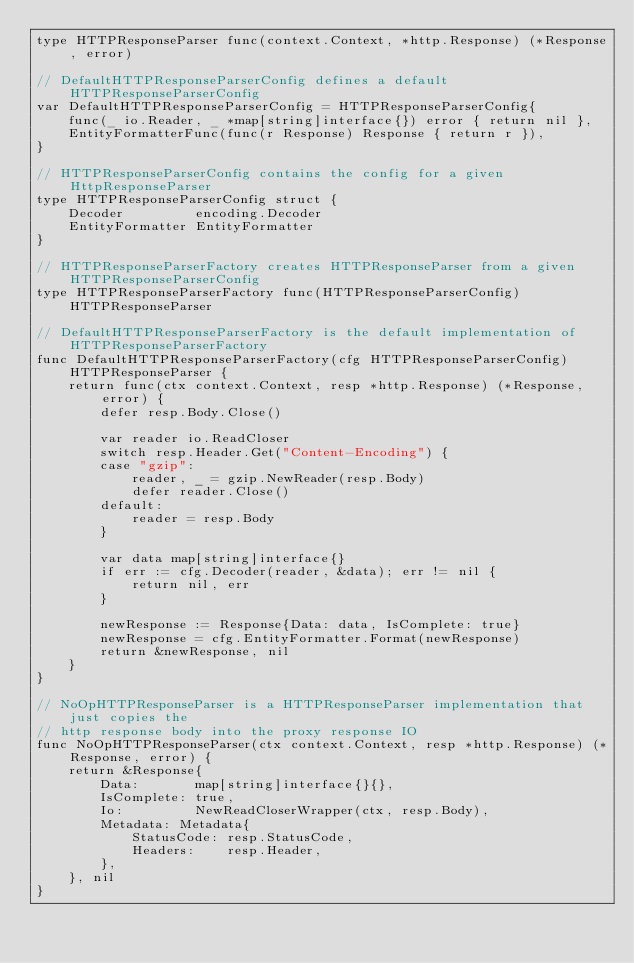<code> <loc_0><loc_0><loc_500><loc_500><_Go_>type HTTPResponseParser func(context.Context, *http.Response) (*Response, error)

// DefaultHTTPResponseParserConfig defines a default HTTPResponseParserConfig
var DefaultHTTPResponseParserConfig = HTTPResponseParserConfig{
	func(_ io.Reader, _ *map[string]interface{}) error { return nil },
	EntityFormatterFunc(func(r Response) Response { return r }),
}

// HTTPResponseParserConfig contains the config for a given HttpResponseParser
type HTTPResponseParserConfig struct {
	Decoder         encoding.Decoder
	EntityFormatter EntityFormatter
}

// HTTPResponseParserFactory creates HTTPResponseParser from a given HTTPResponseParserConfig
type HTTPResponseParserFactory func(HTTPResponseParserConfig) HTTPResponseParser

// DefaultHTTPResponseParserFactory is the default implementation of HTTPResponseParserFactory
func DefaultHTTPResponseParserFactory(cfg HTTPResponseParserConfig) HTTPResponseParser {
	return func(ctx context.Context, resp *http.Response) (*Response, error) {
		defer resp.Body.Close()

		var reader io.ReadCloser
		switch resp.Header.Get("Content-Encoding") {
		case "gzip":
			reader, _ = gzip.NewReader(resp.Body)
			defer reader.Close()
		default:
			reader = resp.Body
		}

		var data map[string]interface{}
		if err := cfg.Decoder(reader, &data); err != nil {
			return nil, err
		}

		newResponse := Response{Data: data, IsComplete: true}
		newResponse = cfg.EntityFormatter.Format(newResponse)
		return &newResponse, nil
	}
}

// NoOpHTTPResponseParser is a HTTPResponseParser implementation that just copies the
// http response body into the proxy response IO
func NoOpHTTPResponseParser(ctx context.Context, resp *http.Response) (*Response, error) {
	return &Response{
		Data:       map[string]interface{}{},
		IsComplete: true,
		Io:         NewReadCloserWrapper(ctx, resp.Body),
		Metadata: Metadata{
			StatusCode: resp.StatusCode,
			Headers:    resp.Header,
		},
	}, nil
}
</code> 